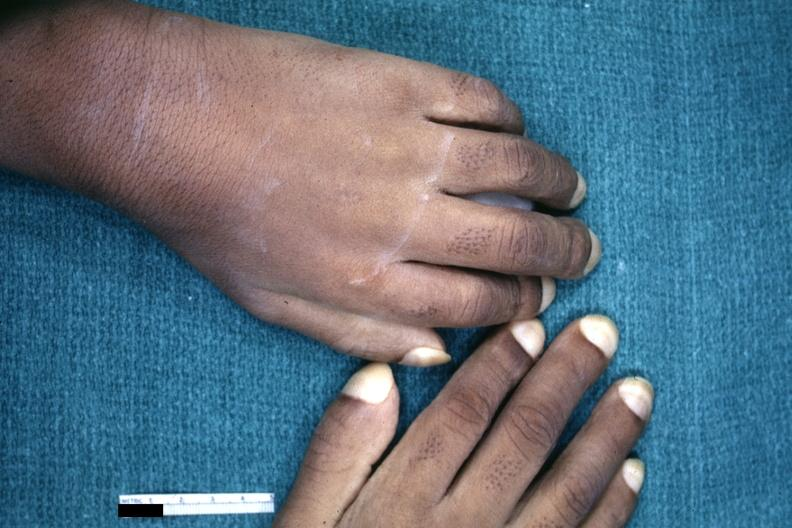re extremities present?
Answer the question using a single word or phrase. Yes 